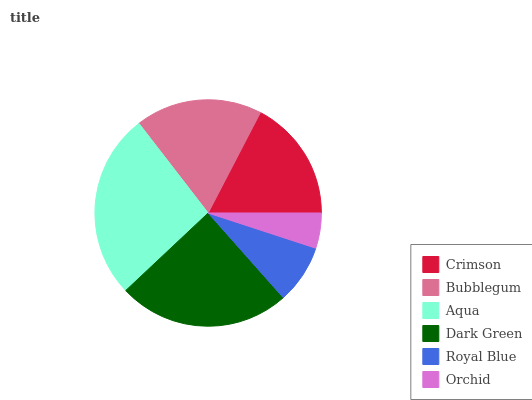Is Orchid the minimum?
Answer yes or no. Yes. Is Aqua the maximum?
Answer yes or no. Yes. Is Bubblegum the minimum?
Answer yes or no. No. Is Bubblegum the maximum?
Answer yes or no. No. Is Bubblegum greater than Crimson?
Answer yes or no. Yes. Is Crimson less than Bubblegum?
Answer yes or no. Yes. Is Crimson greater than Bubblegum?
Answer yes or no. No. Is Bubblegum less than Crimson?
Answer yes or no. No. Is Bubblegum the high median?
Answer yes or no. Yes. Is Crimson the low median?
Answer yes or no. Yes. Is Crimson the high median?
Answer yes or no. No. Is Dark Green the low median?
Answer yes or no. No. 